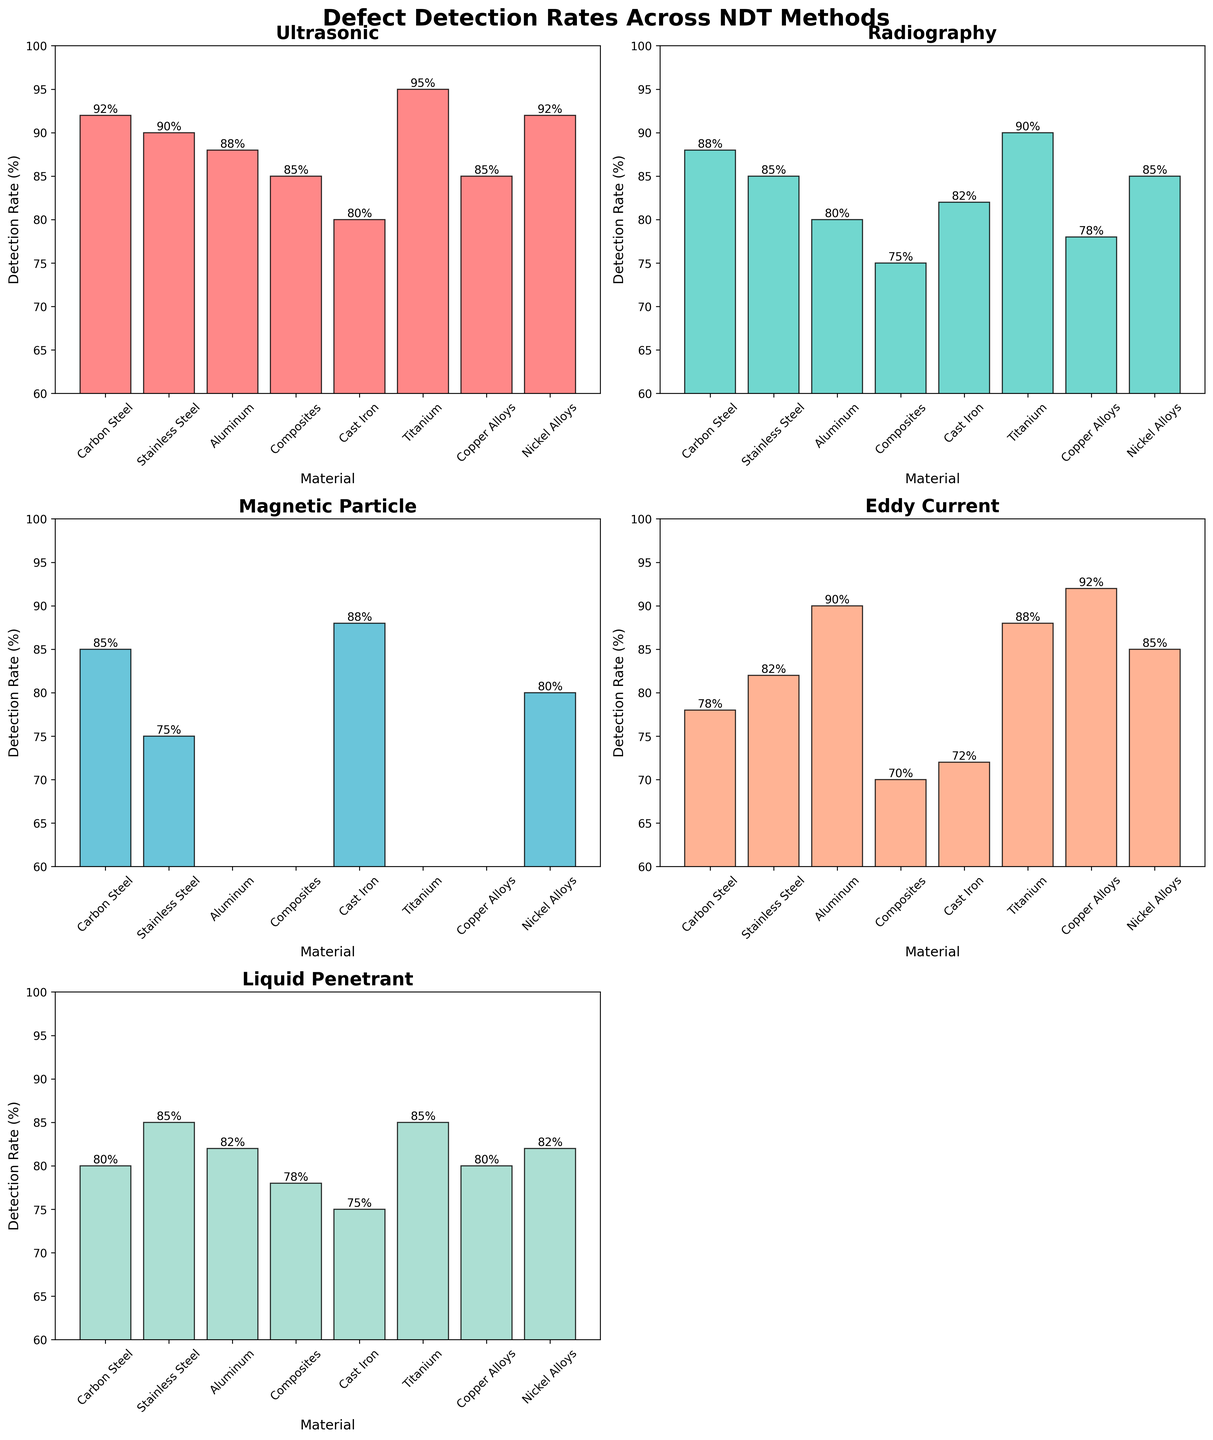Which NDT method shows the highest defect detection rate for Titanium? To determine which NDT method has the highest detection rate for Titanium, find Titanium on the x-axis and identify the tallest bar in that section. The tallest bar represents Ultrasonic testing.
Answer: Ultrasonic What is the difference in detection rates between Ultrasonic and Radiography for Carbon Steel? Look at the bars for Carbon Steel for both Ultrasonic and Radiography methods. The Ultrasonic bar is at 92% and Radiography at 88%. To find the difference, subtract 88 from 92.
Answer: 4% What is the average detection rate of Magnetic Particle testing across all materials? First, identify the detection rates for Magnetic Particle testing for all materials: 85 (Carbon Steel), 75 (Stainless Steel), and 88 (Cast Iron). Others are N/A. The average is calculated as (85 + 75 + 88) / 3.
Answer: 82.67 Which material has the lowest detection rate for Eddy Current testing? Locate the bars for Eddy Current testing and compare their heights. The lowest bar is for Composites at 70%.
Answer: Composites Compare the detection rate of Liquid Penetrant for Copper Alloys and Stainless Steel. Which is higher, and by how much? Identify the bars for Liquid Penetrant for Copper Alloys (80%) and Stainless Steel (85%). The difference is calculated by subtracting 80 from 85.
Answer: Stainless Steel by 5% For which materials is Radiography not applicable (N/A)? Look for bars labeled as N/A for Radiography testing. This is reflected by missing bars for Aluminum, Composites, Titanium, and Copper Alloys.
Answer: Aluminum, Composites, Titanium, Copper Alloys What's the overall trend in defect detection rates for Ultrasonic testing across all materials? Observe the Ultrasonic bars across all materials to note if they are generally high, low, or vary significantly. The bars consistently range from 80% to 95%, indicating generally high detection rates.
Answer: Generally high detection rates How does the detection rate of Ultrasonic compare to Liquid Penetrant for Nickel Alloys? Check the bars for Ultrasonic (92%) and Liquid Penetrant (82%) for Nickel Alloys. Compare the heights to determine that Ultrasonic is higher.
Answer: Ultrasonic is higher What’s the median defect detection rate for Radiography across all applicable materials? Identify the applicable detection rates for Radiography (88, 85, 80, 75, 82, 90, 85). Order them (75, 80, 82, 85, 85, 88, 90) and find the middle value, which is 85.
Answer: 85 